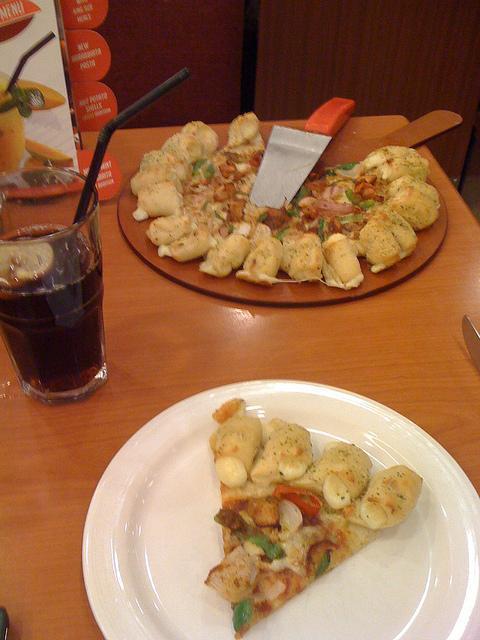How many slices of pizza are on the white plate?
Give a very brief answer. 1. How many pizzas are there?
Give a very brief answer. 2. 